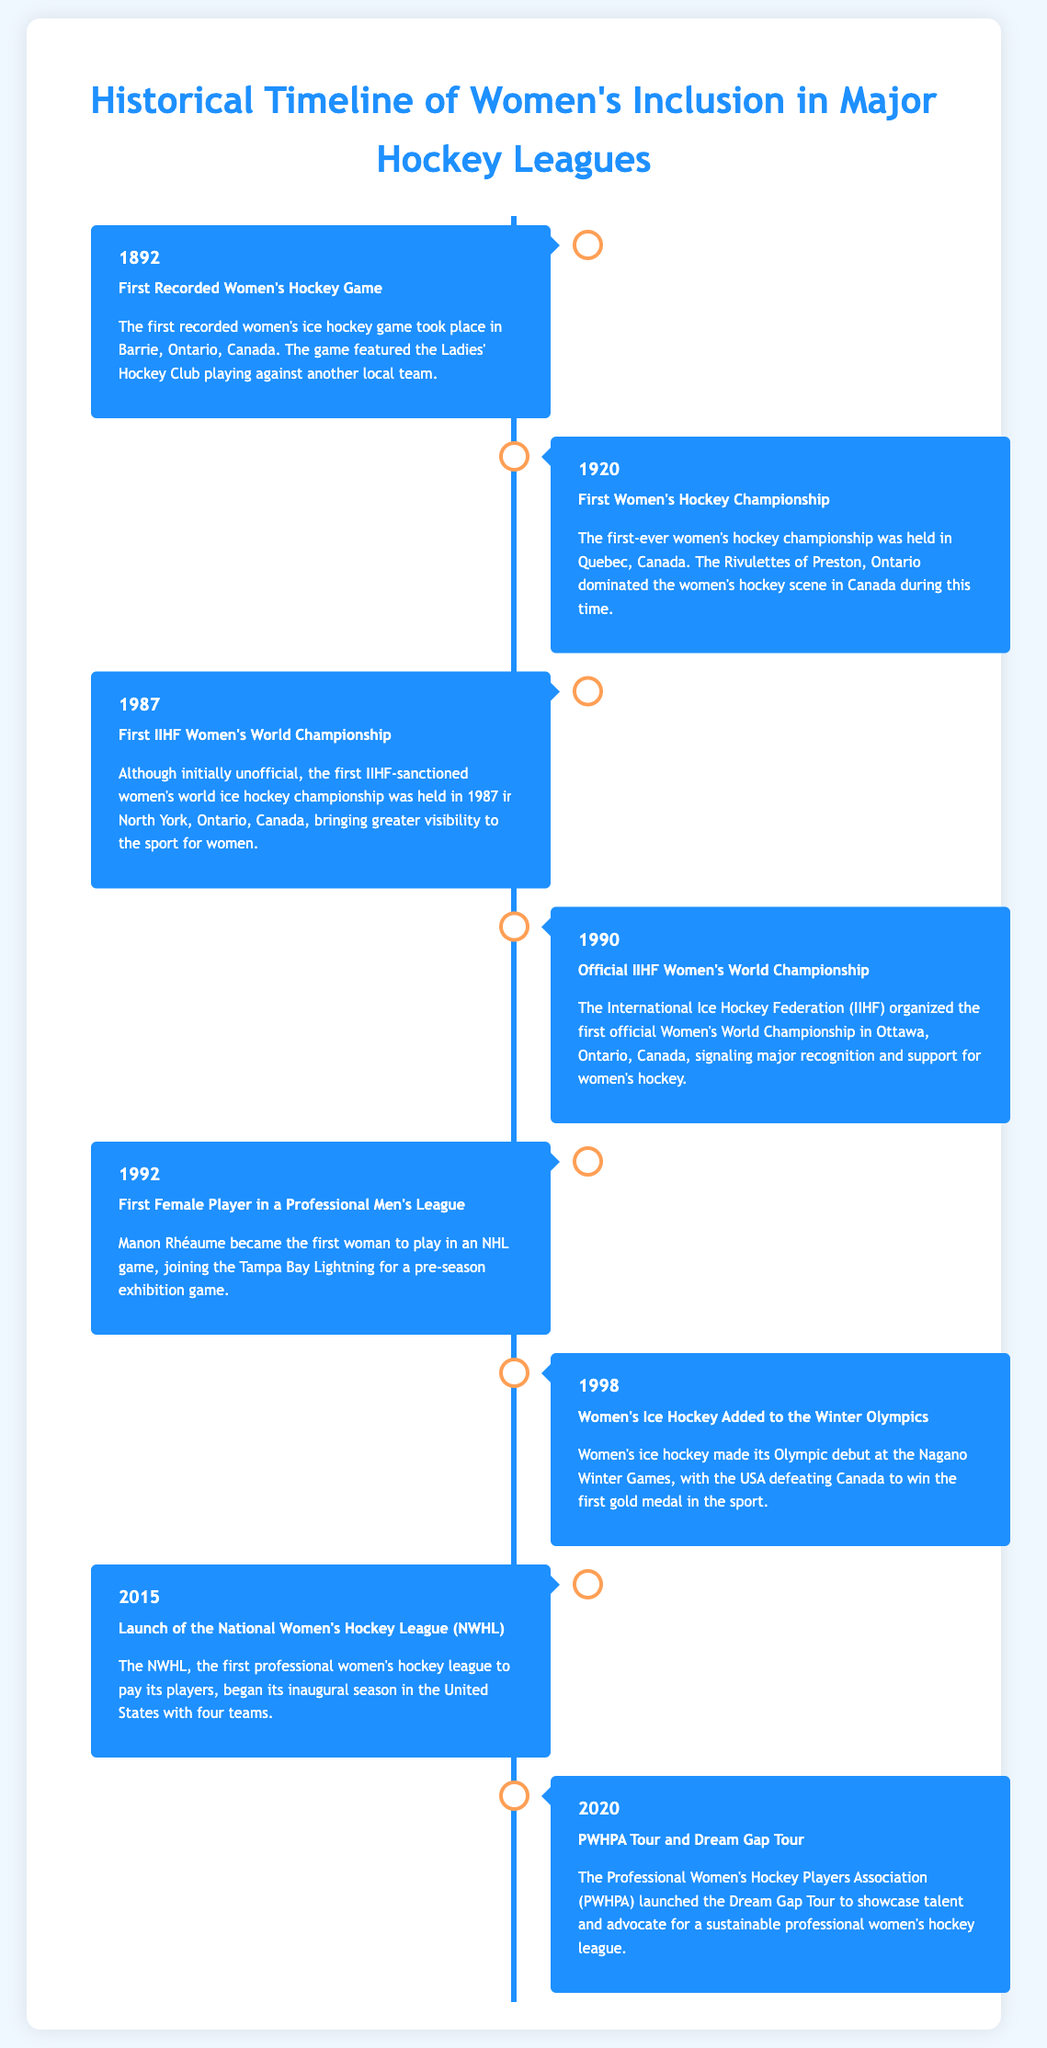What year did the first recorded women's hockey game take place? The document states that the first recorded women's hockey game occurred in Barrie, Ontario, Canada in 1892.
Answer: 1892 Who was the first female player in a professional men's league? The document identifies Manon Rhéaume as the first woman to play in an NHL game.
Answer: Manon Rhéaume What significant event happened in women's hockey in 1998? The document mentions that women's ice hockey was added to the Winter Olympics in 1998.
Answer: Winter Olympics Which league was launched in 2015? According to the document, the National Women's Hockey League (NWHL) was launched in 2015.
Answer: NWHL What was the primary purpose of the PWHPA Dream Gap Tour launched in 2020? The document explains that the Dream Gap Tour was intended to showcase talent and advocate for a sustainable professional women's hockey league.
Answer: Advocate for a sustainable professional women's hockey league When was the first official IIHF Women's World Championship held? The document states that the first official Women's World Championship occurred in 1990.
Answer: 1990 What event marked the beginning of major recognition and support for women's hockey? The document highlights the organization of the first official Women's World Championship by the IIHF in 1990 as significant recognition.
Answer: First official Women's World Championship Which team dominated women's hockey in Canada during the first championship in 1920? The document notes that the Rivulettes of Preston, Ontario, dominated women's hockey during that time.
Answer: Rivulettes of Preston, Ontario 